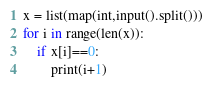<code> <loc_0><loc_0><loc_500><loc_500><_Python_>x = list(map(int,input().split()))
for i in range(len(x)):
    if x[i]==0:
        print(i+1)</code> 